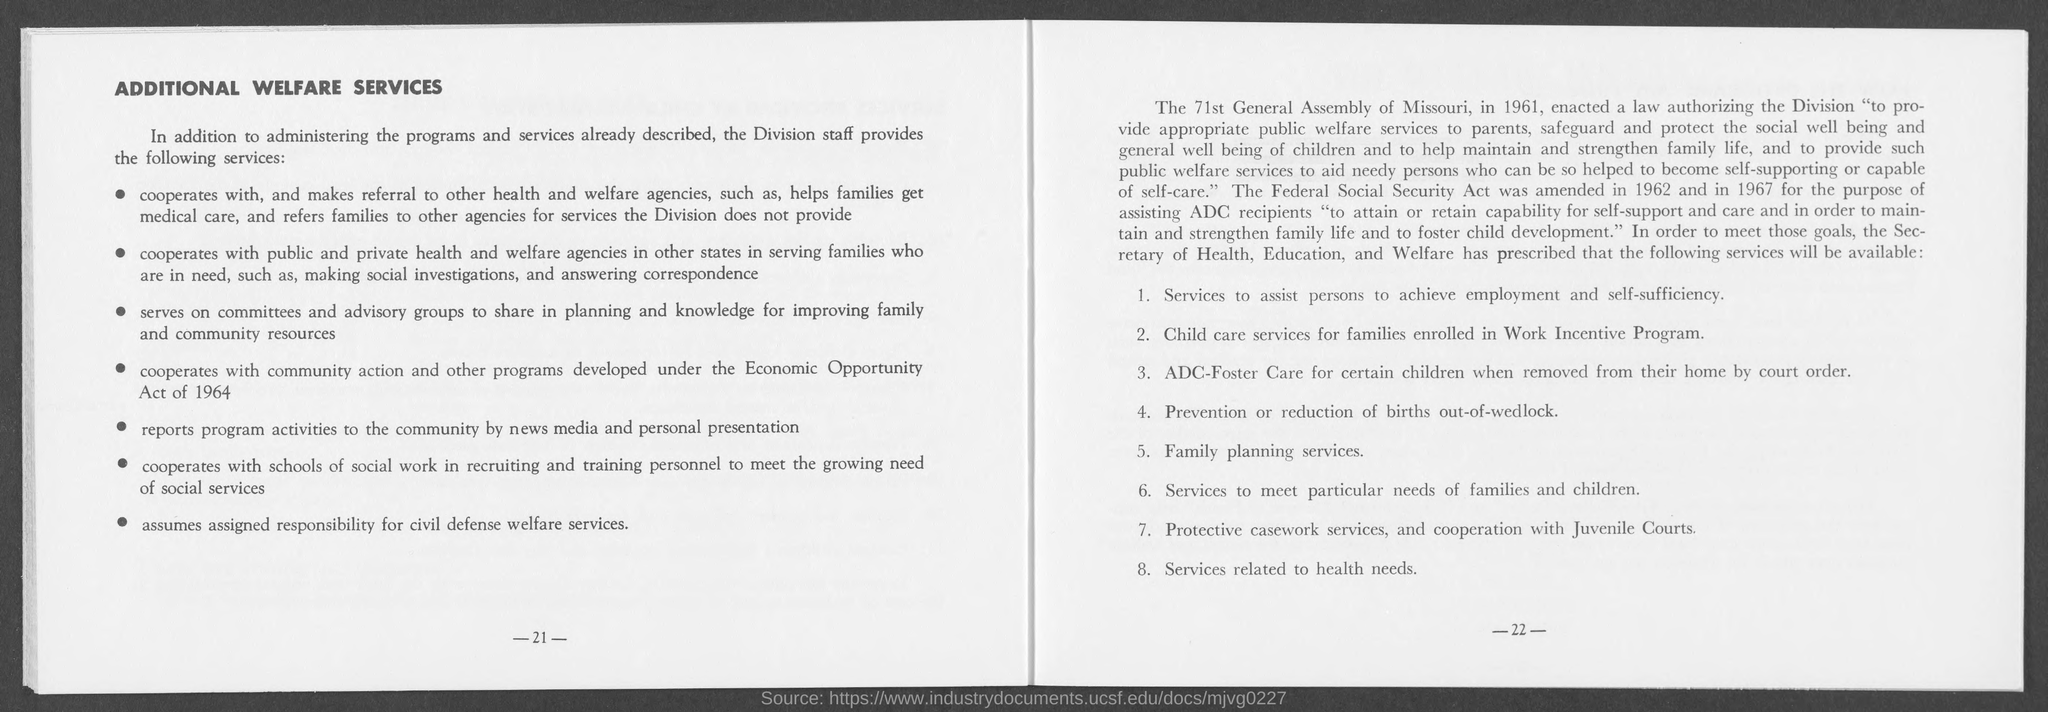What is the number at bottom of the left page?
Offer a very short reply. 21. What is the page number at bottom of right page?
Your answer should be very brief. 22. What is the title at top of left page?
Your answer should be compact. Additional Welfare Services. 